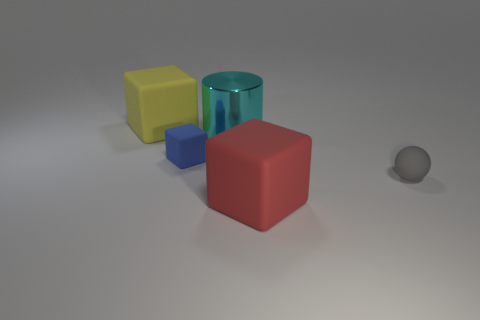Add 3 big cyan objects. How many objects exist? 8 Subtract all spheres. How many objects are left? 4 Add 3 small blue blocks. How many small blue blocks are left? 4 Add 2 small blue matte blocks. How many small blue matte blocks exist? 3 Subtract 1 gray spheres. How many objects are left? 4 Subtract all matte blocks. Subtract all red things. How many objects are left? 1 